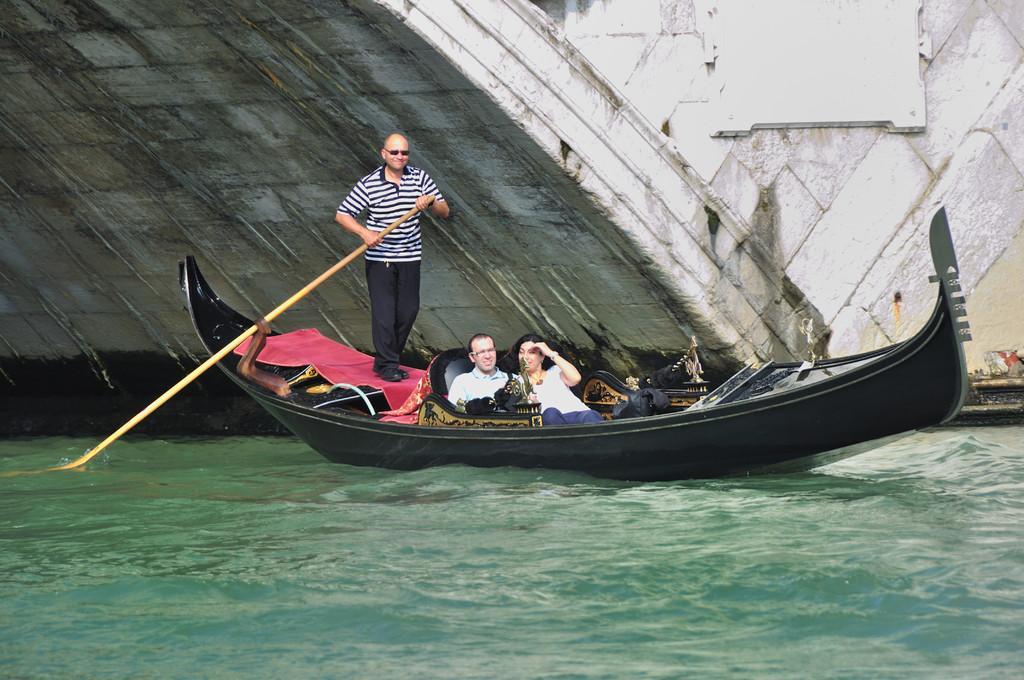In one or two sentences, can you explain what this image depicts? This image consists of a boat in black color. There are three persons in the boat. At the bottom, there is water. In the background, there are walls made up of concrete. It looks like a bridge. 